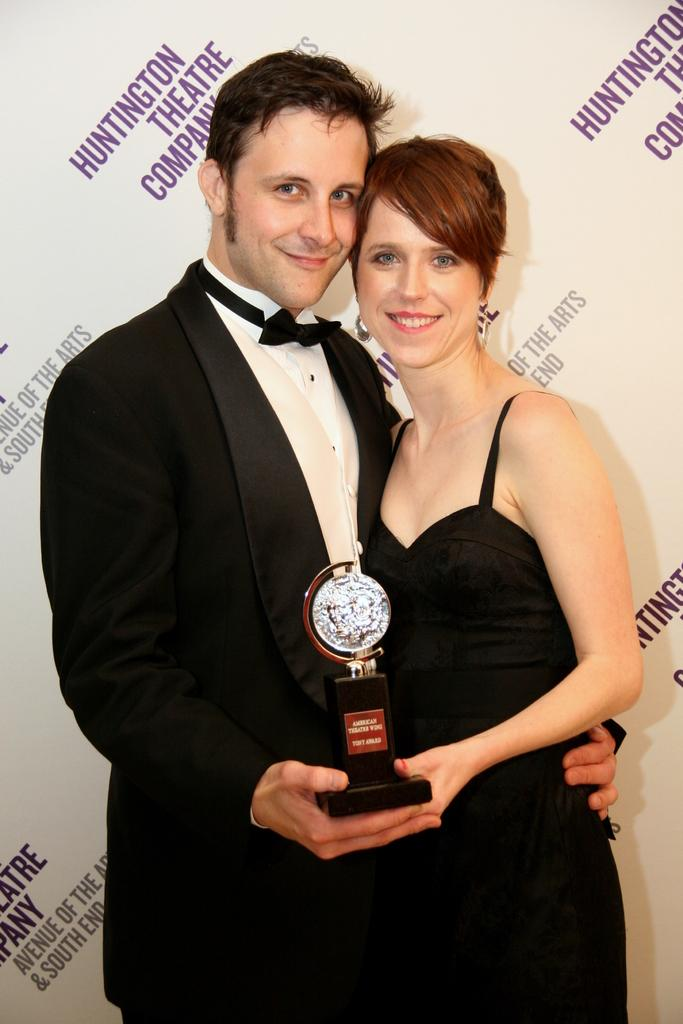<image>
Provide a brief description of the given image. Two people are holding an award in front of a wall that says Huntington Theatre Company. 